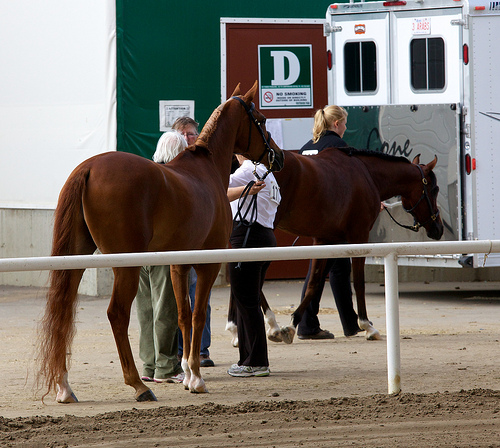<image>
Is the woman to the left of the horse? Yes. From this viewpoint, the woman is positioned to the left side relative to the horse. Where is the horse in relation to the lady? Is it behind the lady? No. The horse is not behind the lady. From this viewpoint, the horse appears to be positioned elsewhere in the scene. 